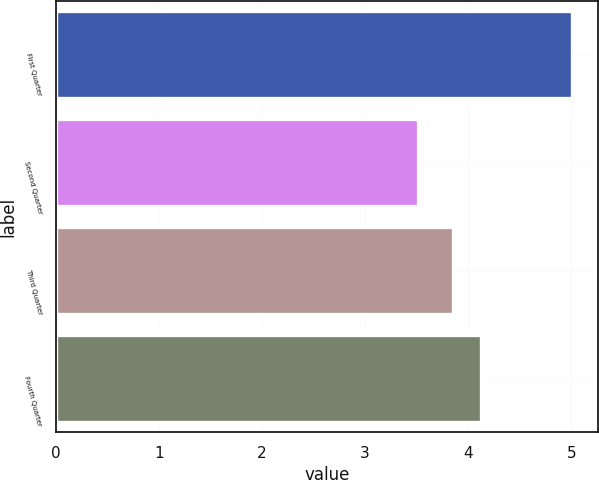Convert chart. <chart><loc_0><loc_0><loc_500><loc_500><bar_chart><fcel>First Quarter<fcel>Second Quarter<fcel>Third Quarter<fcel>Fourth Quarter<nl><fcel>5.01<fcel>3.51<fcel>3.85<fcel>4.12<nl></chart> 